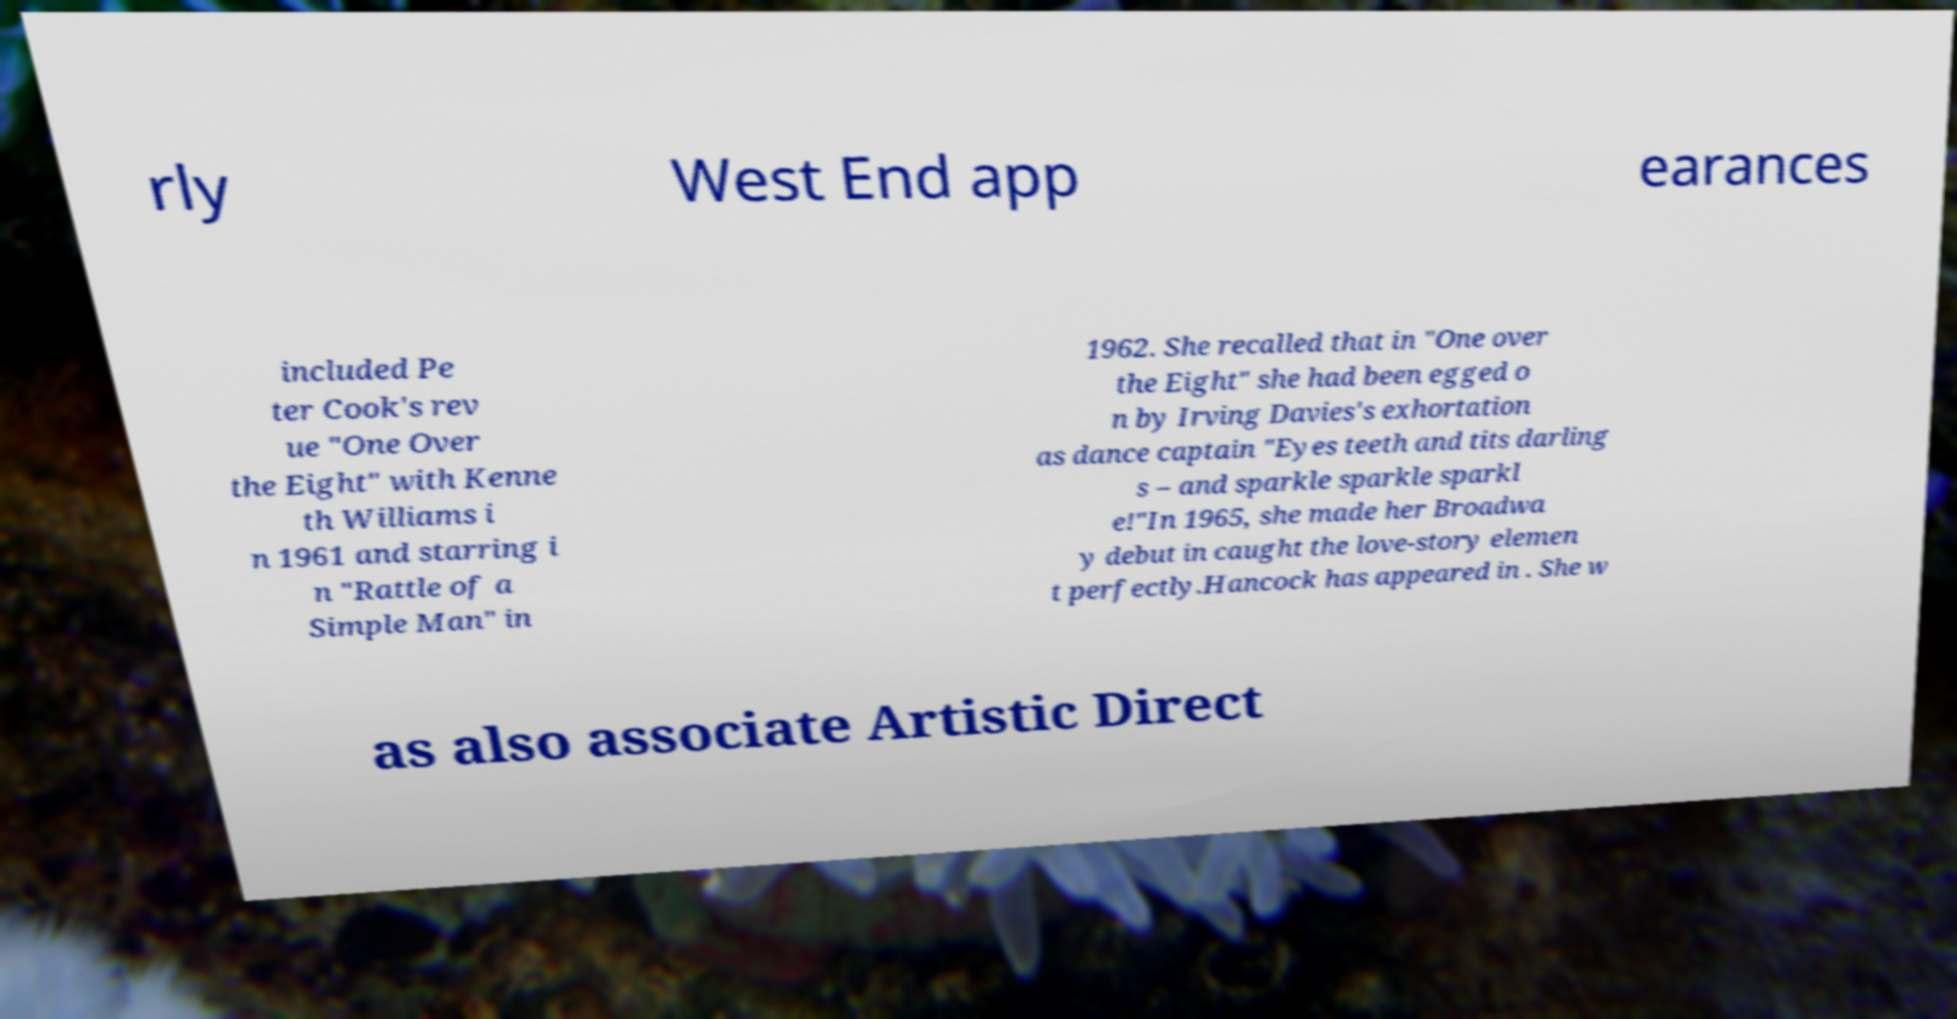Can you accurately transcribe the text from the provided image for me? rly West End app earances included Pe ter Cook's rev ue "One Over the Eight" with Kenne th Williams i n 1961 and starring i n "Rattle of a Simple Man" in 1962. She recalled that in "One over the Eight" she had been egged o n by Irving Davies's exhortation as dance captain "Eyes teeth and tits darling s – and sparkle sparkle sparkl e!"In 1965, she made her Broadwa y debut in caught the love-story elemen t perfectly.Hancock has appeared in . She w as also associate Artistic Direct 